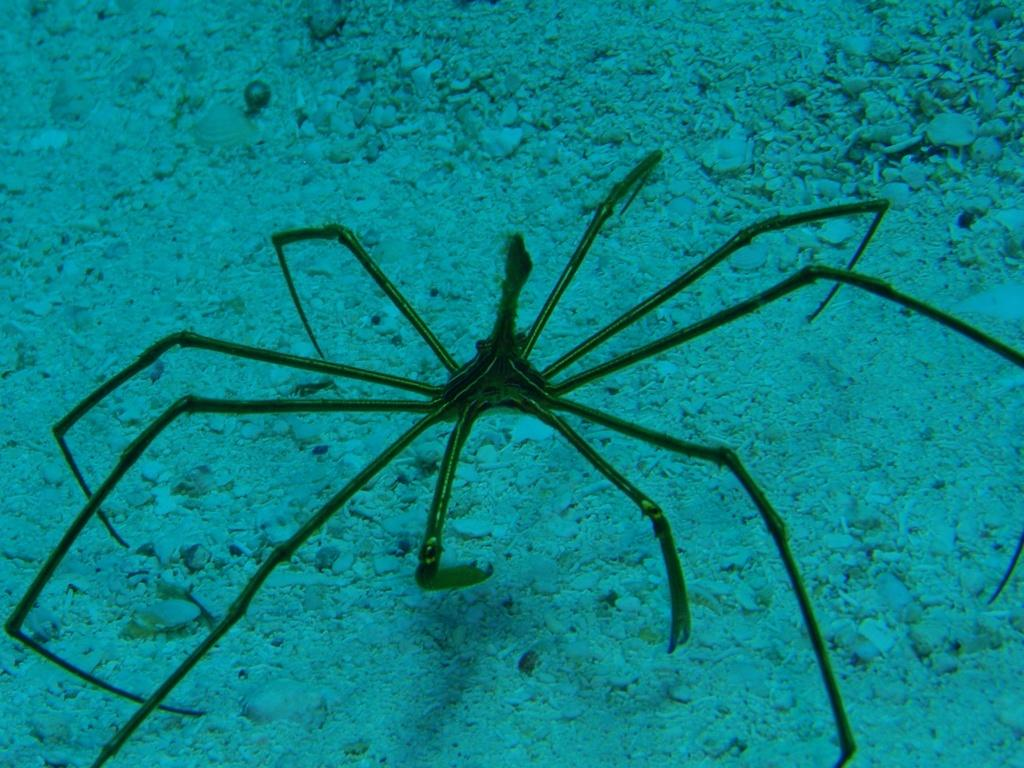Where was the image taken? The image is taken underwater. What can be seen in the center of the image? There is a water animal in the center of the image. What is visible at the bottom of the image? There are stones at the bottom of the image. How many children are playing in the lake in the image? There are no children or lakes present in the image; it is taken underwater and features a water animal and stones. 